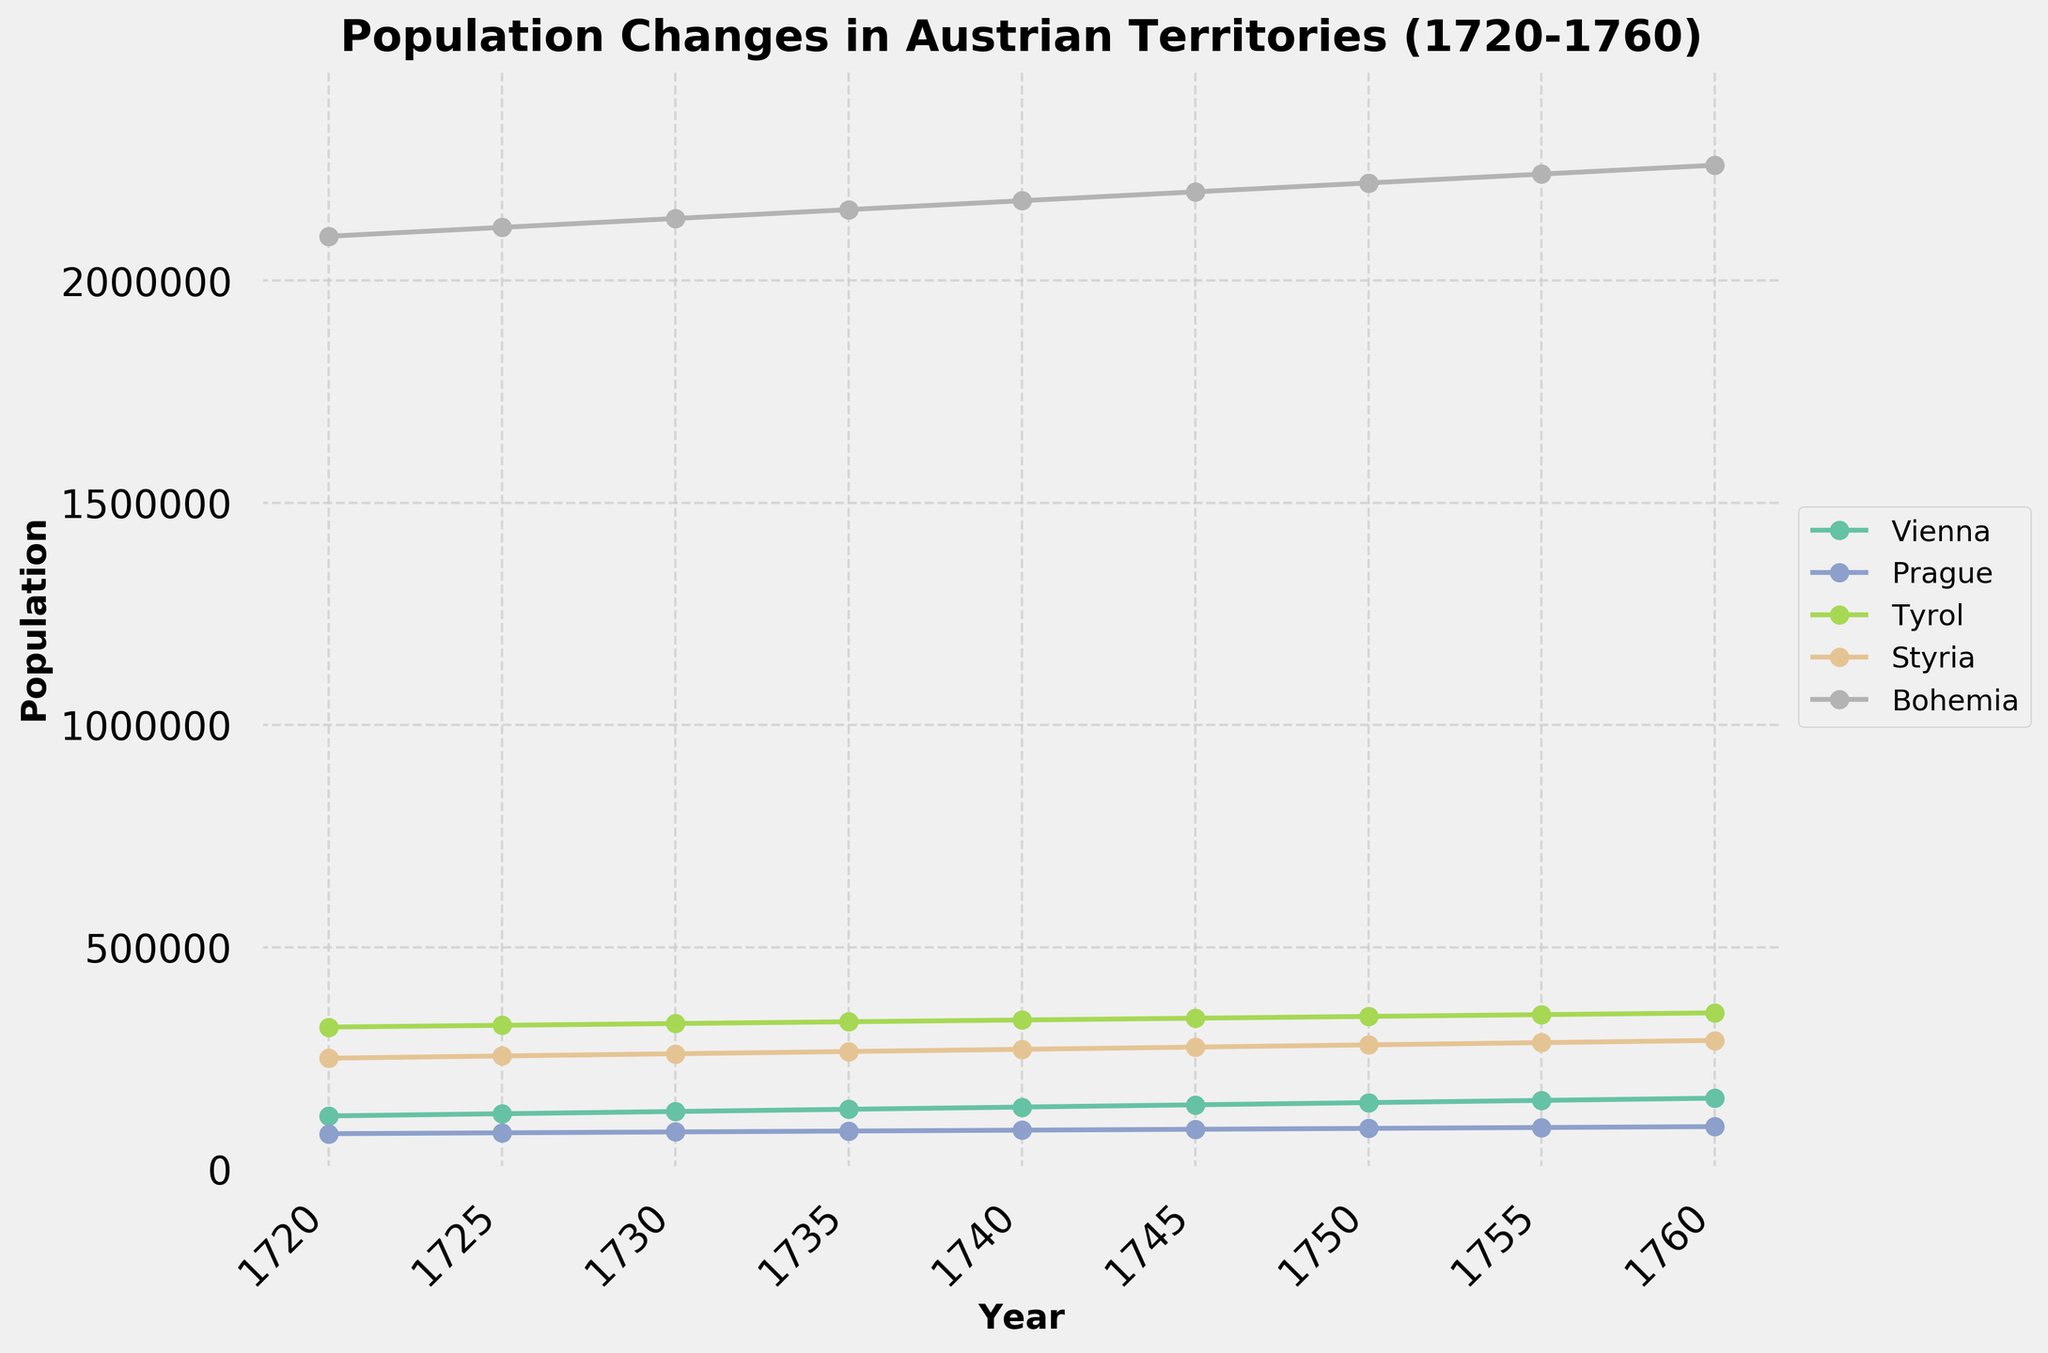What is the title of the figure? The title of the figure is usually at the top and is often in a larger font compared to other text elements. In this plot, the title is clearly displayed.
Answer: Population Changes in Austrian Territories (1720-1760) Which region had the highest population in 1720? To determine the region with the highest population, look at the y-values for each region at the year 1720. The highest y-value corresponds to the highest population.
Answer: Bohemia What is the population of Tyrol in 1750? Find the line representing Tyrol, and look for the data point corresponding to the year 1750. The y-axis value at that point indicates the population.
Answer: 344,000 Which two regions had the closest population in 1725, and how close were they? Compare the y-values for all regions at year 1725 and identify the two populations that are nearest to each other. Calculate their difference.
Answer: Prague and Vienna, 43,000 (125,000 - 82,000) How has the population of Vienna changed from 1720 to 1760? Observe the trend of the line representing Vienna from 1720 to 1760, noting the population values at both ends of the time series. Calculate the difference between these two values.
Answer: Increased by 40,000 (160,000 - 120,000) Which region shows the most consistent population growth over the period? A consistent growth means the line is smooth and steadily increasing. Compare the lines for each region to determine which one shows the least fluctuation and a steady increase.
Answer: Styria In which year did Prague reach a population of 90,000? Trace the line for Prague until the y-value reaches 90,000 and find the corresponding year on the x-axis.
Answer: 1745 What is the total population of all regions in the year 1755? Sum the y-values for all regions at the year 1755.
Answer: 2,783,000 (155,000 + 94,000 + 348,000 + 285,000 + 2,240,000) Which region had the smallest growth rate from 1720 to 1760? Calculate the growth rate for each region as (Population in 1760 - Population in 1720) / Population in 1720. Compare these values to find the smallest one.
Answer: Prague (20.00%) 